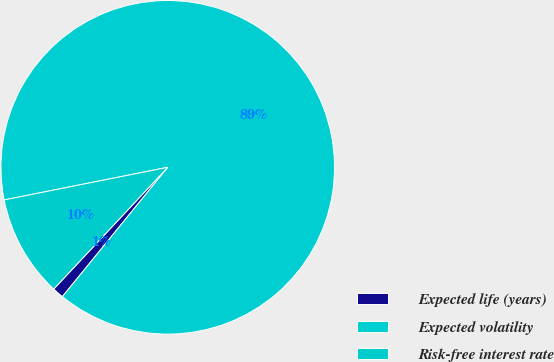Convert chart. <chart><loc_0><loc_0><loc_500><loc_500><pie_chart><fcel>Expected life (years)<fcel>Expected volatility<fcel>Risk-free interest rate<nl><fcel>1.1%<fcel>89.02%<fcel>9.89%<nl></chart> 